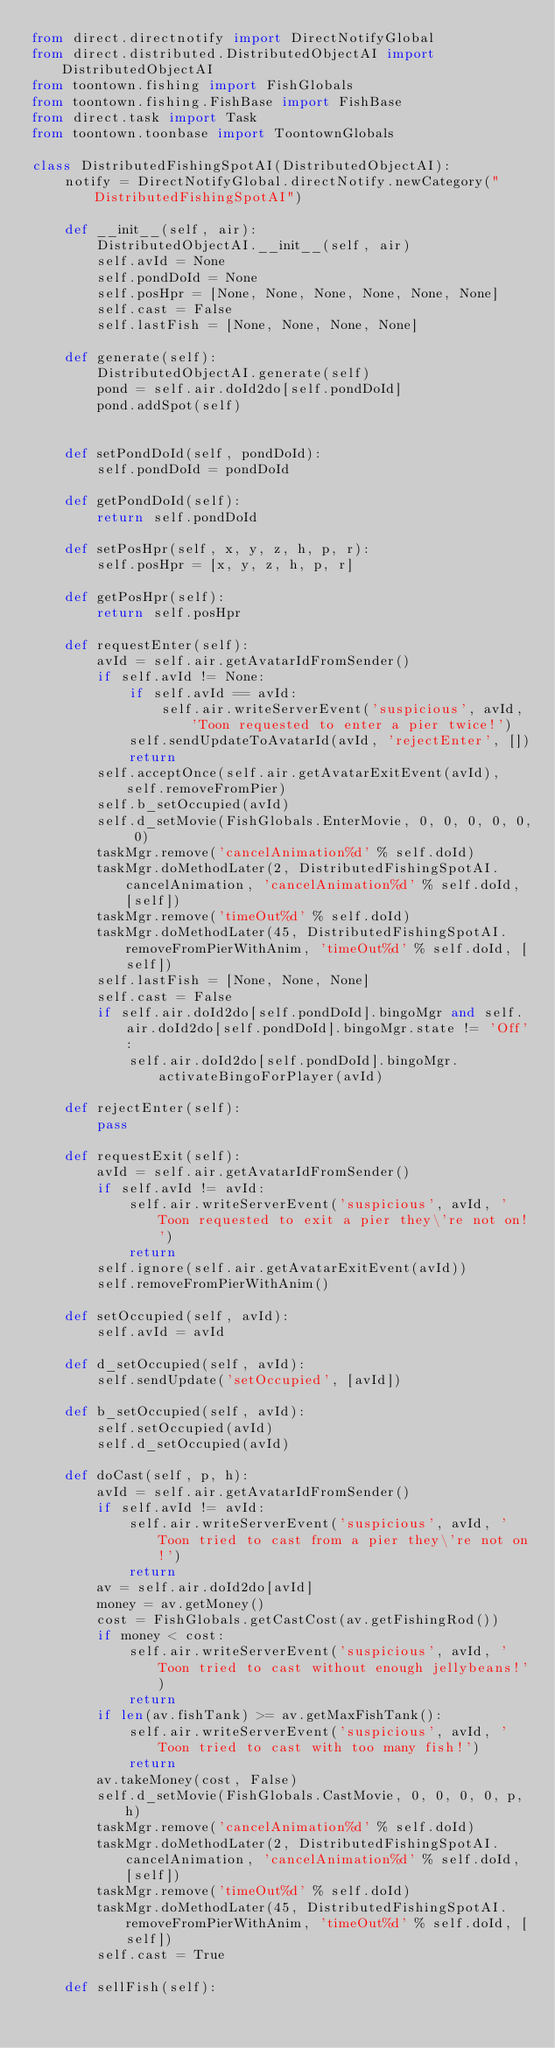Convert code to text. <code><loc_0><loc_0><loc_500><loc_500><_Python_>from direct.directnotify import DirectNotifyGlobal
from direct.distributed.DistributedObjectAI import DistributedObjectAI
from toontown.fishing import FishGlobals
from toontown.fishing.FishBase import FishBase
from direct.task import Task
from toontown.toonbase import ToontownGlobals

class DistributedFishingSpotAI(DistributedObjectAI):
    notify = DirectNotifyGlobal.directNotify.newCategory("DistributedFishingSpotAI")

    def __init__(self, air):
        DistributedObjectAI.__init__(self, air)
        self.avId = None
        self.pondDoId = None
        self.posHpr = [None, None, None, None, None, None]
        self.cast = False
        self.lastFish = [None, None, None, None]

    def generate(self):
        DistributedObjectAI.generate(self)
        pond = self.air.doId2do[self.pondDoId]
        pond.addSpot(self)


    def setPondDoId(self, pondDoId):
        self.pondDoId = pondDoId

    def getPondDoId(self):
        return self.pondDoId

    def setPosHpr(self, x, y, z, h, p, r):
        self.posHpr = [x, y, z, h, p, r]

    def getPosHpr(self):
        return self.posHpr

    def requestEnter(self):
        avId = self.air.getAvatarIdFromSender()
        if self.avId != None:
            if self.avId == avId:
                self.air.writeServerEvent('suspicious', avId, 'Toon requested to enter a pier twice!')
            self.sendUpdateToAvatarId(avId, 'rejectEnter', [])
            return
        self.acceptOnce(self.air.getAvatarExitEvent(avId), self.removeFromPier)
        self.b_setOccupied(avId)
        self.d_setMovie(FishGlobals.EnterMovie, 0, 0, 0, 0, 0, 0)
        taskMgr.remove('cancelAnimation%d' % self.doId)
        taskMgr.doMethodLater(2, DistributedFishingSpotAI.cancelAnimation, 'cancelAnimation%d' % self.doId, [self])
        taskMgr.remove('timeOut%d' % self.doId)
        taskMgr.doMethodLater(45, DistributedFishingSpotAI.removeFromPierWithAnim, 'timeOut%d' % self.doId, [self])
        self.lastFish = [None, None, None]
        self.cast = False
        if self.air.doId2do[self.pondDoId].bingoMgr and self.air.doId2do[self.pondDoId].bingoMgr.state != 'Off':
            self.air.doId2do[self.pondDoId].bingoMgr.activateBingoForPlayer(avId)

    def rejectEnter(self):
        pass

    def requestExit(self):
        avId = self.air.getAvatarIdFromSender()
        if self.avId != avId:
            self.air.writeServerEvent('suspicious', avId, 'Toon requested to exit a pier they\'re not on!')
            return
        self.ignore(self.air.getAvatarExitEvent(avId))
        self.removeFromPierWithAnim()

    def setOccupied(self, avId):
        self.avId = avId

    def d_setOccupied(self, avId):
        self.sendUpdate('setOccupied', [avId])

    def b_setOccupied(self, avId):
        self.setOccupied(avId)
        self.d_setOccupied(avId)

    def doCast(self, p, h):
        avId = self.air.getAvatarIdFromSender()
        if self.avId != avId:
            self.air.writeServerEvent('suspicious', avId, 'Toon tried to cast from a pier they\'re not on!')
            return
        av = self.air.doId2do[avId]
        money = av.getMoney()
        cost = FishGlobals.getCastCost(av.getFishingRod())
        if money < cost:
            self.air.writeServerEvent('suspicious', avId, 'Toon tried to cast without enough jellybeans!')
            return
        if len(av.fishTank) >= av.getMaxFishTank():
            self.air.writeServerEvent('suspicious', avId, 'Toon tried to cast with too many fish!')
            return
        av.takeMoney(cost, False)
        self.d_setMovie(FishGlobals.CastMovie, 0, 0, 0, 0, p, h)
        taskMgr.remove('cancelAnimation%d' % self.doId)
        taskMgr.doMethodLater(2, DistributedFishingSpotAI.cancelAnimation, 'cancelAnimation%d' % self.doId, [self])
        taskMgr.remove('timeOut%d' % self.doId)
        taskMgr.doMethodLater(45, DistributedFishingSpotAI.removeFromPierWithAnim, 'timeOut%d' % self.doId, [self])
        self.cast = True

    def sellFish(self):</code> 